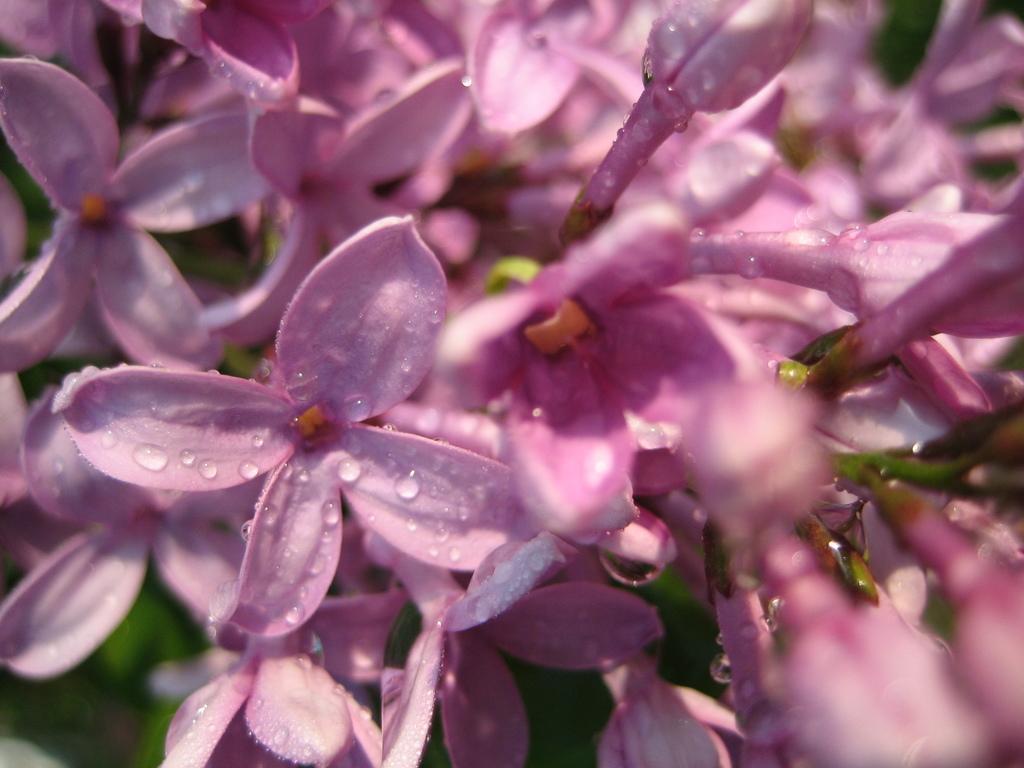Please provide a concise description of this image. In this image there are group of flowers truncated. 